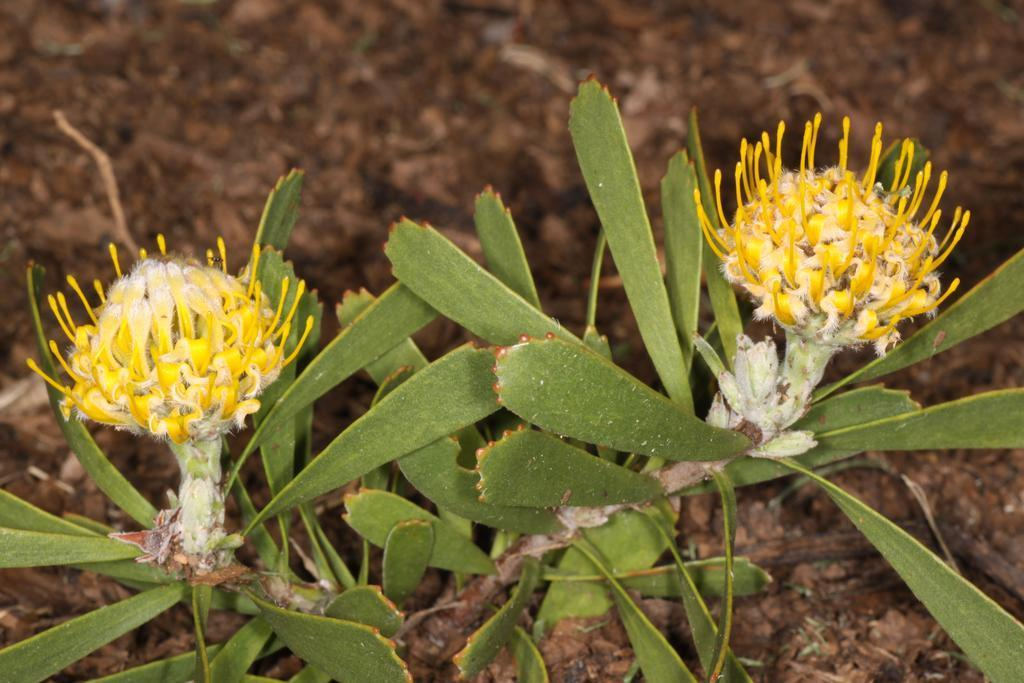What type of plant life is present in the image? There are flower buds and a plant in the image. Can you describe the stage of growth of the plant life? The flower buds suggest that the plants are in the process of blooming. What can be seen in the background of the image? The ground is visible in the background of the image. What type of furniture is present in the image? There is no furniture present in the image; it features flower buds and a plant. What season is being celebrated in the image? The image does not depict a specific season or celebration, such as summer or a birthday. 